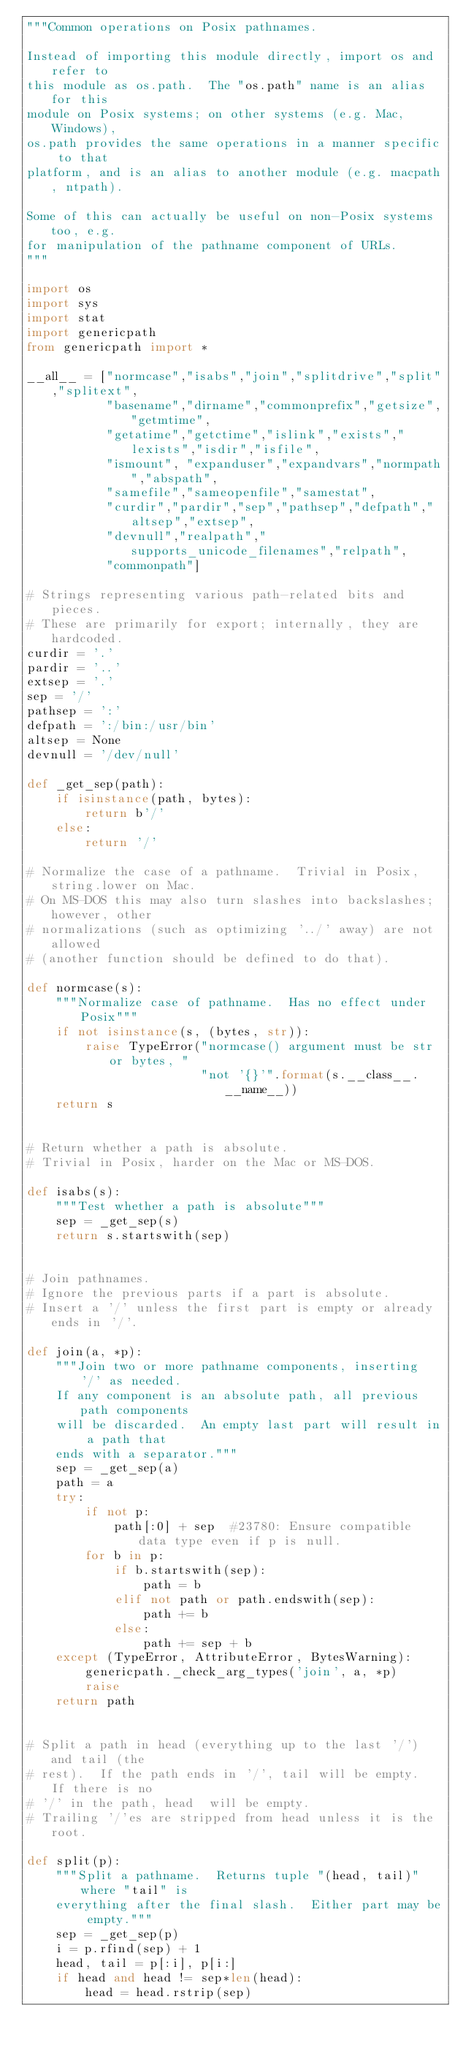<code> <loc_0><loc_0><loc_500><loc_500><_Python_>"""Common operations on Posix pathnames.

Instead of importing this module directly, import os and refer to
this module as os.path.  The "os.path" name is an alias for this
module on Posix systems; on other systems (e.g. Mac, Windows),
os.path provides the same operations in a manner specific to that
platform, and is an alias to another module (e.g. macpath, ntpath).

Some of this can actually be useful on non-Posix systems too, e.g.
for manipulation of the pathname component of URLs.
"""

import os
import sys
import stat
import genericpath
from genericpath import *

__all__ = ["normcase","isabs","join","splitdrive","split","splitext",
           "basename","dirname","commonprefix","getsize","getmtime",
           "getatime","getctime","islink","exists","lexists","isdir","isfile",
           "ismount", "expanduser","expandvars","normpath","abspath",
           "samefile","sameopenfile","samestat",
           "curdir","pardir","sep","pathsep","defpath","altsep","extsep",
           "devnull","realpath","supports_unicode_filenames","relpath",
           "commonpath"]

# Strings representing various path-related bits and pieces.
# These are primarily for export; internally, they are hardcoded.
curdir = '.'
pardir = '..'
extsep = '.'
sep = '/'
pathsep = ':'
defpath = ':/bin:/usr/bin'
altsep = None
devnull = '/dev/null'

def _get_sep(path):
    if isinstance(path, bytes):
        return b'/'
    else:
        return '/'

# Normalize the case of a pathname.  Trivial in Posix, string.lower on Mac.
# On MS-DOS this may also turn slashes into backslashes; however, other
# normalizations (such as optimizing '../' away) are not allowed
# (another function should be defined to do that).

def normcase(s):
    """Normalize case of pathname.  Has no effect under Posix"""
    if not isinstance(s, (bytes, str)):
        raise TypeError("normcase() argument must be str or bytes, "
                        "not '{}'".format(s.__class__.__name__))
    return s


# Return whether a path is absolute.
# Trivial in Posix, harder on the Mac or MS-DOS.

def isabs(s):
    """Test whether a path is absolute"""
    sep = _get_sep(s)
    return s.startswith(sep)


# Join pathnames.
# Ignore the previous parts if a part is absolute.
# Insert a '/' unless the first part is empty or already ends in '/'.

def join(a, *p):
    """Join two or more pathname components, inserting '/' as needed.
    If any component is an absolute path, all previous path components
    will be discarded.  An empty last part will result in a path that
    ends with a separator."""
    sep = _get_sep(a)
    path = a
    try:
        if not p:
            path[:0] + sep  #23780: Ensure compatible data type even if p is null.
        for b in p:
            if b.startswith(sep):
                path = b
            elif not path or path.endswith(sep):
                path += b
            else:
                path += sep + b
    except (TypeError, AttributeError, BytesWarning):
        genericpath._check_arg_types('join', a, *p)
        raise
    return path


# Split a path in head (everything up to the last '/') and tail (the
# rest).  If the path ends in '/', tail will be empty.  If there is no
# '/' in the path, head  will be empty.
# Trailing '/'es are stripped from head unless it is the root.

def split(p):
    """Split a pathname.  Returns tuple "(head, tail)" where "tail" is
    everything after the final slash.  Either part may be empty."""
    sep = _get_sep(p)
    i = p.rfind(sep) + 1
    head, tail = p[:i], p[i:]
    if head and head != sep*len(head):
        head = head.rstrip(sep)</code> 